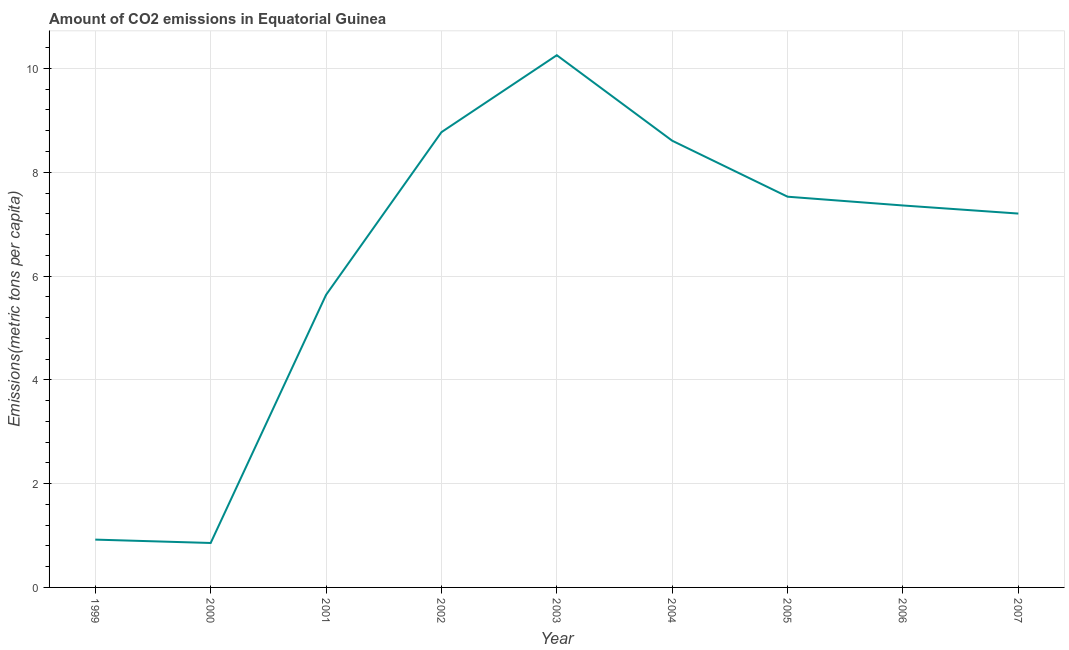What is the amount of co2 emissions in 2002?
Your answer should be compact. 8.77. Across all years, what is the maximum amount of co2 emissions?
Ensure brevity in your answer.  10.26. Across all years, what is the minimum amount of co2 emissions?
Your response must be concise. 0.86. In which year was the amount of co2 emissions minimum?
Make the answer very short. 2000. What is the sum of the amount of co2 emissions?
Your response must be concise. 57.14. What is the difference between the amount of co2 emissions in 2000 and 2006?
Provide a short and direct response. -6.5. What is the average amount of co2 emissions per year?
Your answer should be compact. 6.35. What is the median amount of co2 emissions?
Provide a succinct answer. 7.36. In how many years, is the amount of co2 emissions greater than 0.8 metric tons per capita?
Provide a short and direct response. 9. Do a majority of the years between 2006 and 2007 (inclusive) have amount of co2 emissions greater than 5.2 metric tons per capita?
Keep it short and to the point. Yes. What is the ratio of the amount of co2 emissions in 2004 to that in 2007?
Keep it short and to the point. 1.19. What is the difference between the highest and the second highest amount of co2 emissions?
Provide a short and direct response. 1.48. Is the sum of the amount of co2 emissions in 2001 and 2007 greater than the maximum amount of co2 emissions across all years?
Keep it short and to the point. Yes. What is the difference between the highest and the lowest amount of co2 emissions?
Ensure brevity in your answer.  9.4. Does the amount of co2 emissions monotonically increase over the years?
Offer a very short reply. No. How many lines are there?
Offer a terse response. 1. What is the title of the graph?
Ensure brevity in your answer.  Amount of CO2 emissions in Equatorial Guinea. What is the label or title of the Y-axis?
Your response must be concise. Emissions(metric tons per capita). What is the Emissions(metric tons per capita) of 1999?
Provide a succinct answer. 0.92. What is the Emissions(metric tons per capita) in 2000?
Ensure brevity in your answer.  0.86. What is the Emissions(metric tons per capita) of 2001?
Your answer should be very brief. 5.64. What is the Emissions(metric tons per capita) in 2002?
Make the answer very short. 8.77. What is the Emissions(metric tons per capita) in 2003?
Make the answer very short. 10.26. What is the Emissions(metric tons per capita) in 2004?
Make the answer very short. 8.61. What is the Emissions(metric tons per capita) in 2005?
Ensure brevity in your answer.  7.53. What is the Emissions(metric tons per capita) in 2006?
Your answer should be compact. 7.36. What is the Emissions(metric tons per capita) in 2007?
Ensure brevity in your answer.  7.2. What is the difference between the Emissions(metric tons per capita) in 1999 and 2000?
Your response must be concise. 0.07. What is the difference between the Emissions(metric tons per capita) in 1999 and 2001?
Your answer should be compact. -4.72. What is the difference between the Emissions(metric tons per capita) in 1999 and 2002?
Keep it short and to the point. -7.85. What is the difference between the Emissions(metric tons per capita) in 1999 and 2003?
Ensure brevity in your answer.  -9.33. What is the difference between the Emissions(metric tons per capita) in 1999 and 2004?
Keep it short and to the point. -7.69. What is the difference between the Emissions(metric tons per capita) in 1999 and 2005?
Your response must be concise. -6.61. What is the difference between the Emissions(metric tons per capita) in 1999 and 2006?
Your response must be concise. -6.44. What is the difference between the Emissions(metric tons per capita) in 1999 and 2007?
Your answer should be compact. -6.28. What is the difference between the Emissions(metric tons per capita) in 2000 and 2001?
Give a very brief answer. -4.78. What is the difference between the Emissions(metric tons per capita) in 2000 and 2002?
Make the answer very short. -7.92. What is the difference between the Emissions(metric tons per capita) in 2000 and 2003?
Ensure brevity in your answer.  -9.4. What is the difference between the Emissions(metric tons per capita) in 2000 and 2004?
Give a very brief answer. -7.75. What is the difference between the Emissions(metric tons per capita) in 2000 and 2005?
Offer a very short reply. -6.67. What is the difference between the Emissions(metric tons per capita) in 2000 and 2006?
Give a very brief answer. -6.5. What is the difference between the Emissions(metric tons per capita) in 2000 and 2007?
Make the answer very short. -6.35. What is the difference between the Emissions(metric tons per capita) in 2001 and 2002?
Ensure brevity in your answer.  -3.14. What is the difference between the Emissions(metric tons per capita) in 2001 and 2003?
Offer a terse response. -4.62. What is the difference between the Emissions(metric tons per capita) in 2001 and 2004?
Provide a short and direct response. -2.97. What is the difference between the Emissions(metric tons per capita) in 2001 and 2005?
Your answer should be compact. -1.89. What is the difference between the Emissions(metric tons per capita) in 2001 and 2006?
Offer a terse response. -1.72. What is the difference between the Emissions(metric tons per capita) in 2001 and 2007?
Make the answer very short. -1.57. What is the difference between the Emissions(metric tons per capita) in 2002 and 2003?
Provide a succinct answer. -1.48. What is the difference between the Emissions(metric tons per capita) in 2002 and 2004?
Ensure brevity in your answer.  0.16. What is the difference between the Emissions(metric tons per capita) in 2002 and 2005?
Make the answer very short. 1.24. What is the difference between the Emissions(metric tons per capita) in 2002 and 2006?
Keep it short and to the point. 1.41. What is the difference between the Emissions(metric tons per capita) in 2002 and 2007?
Ensure brevity in your answer.  1.57. What is the difference between the Emissions(metric tons per capita) in 2003 and 2004?
Your response must be concise. 1.65. What is the difference between the Emissions(metric tons per capita) in 2003 and 2005?
Provide a succinct answer. 2.73. What is the difference between the Emissions(metric tons per capita) in 2003 and 2006?
Ensure brevity in your answer.  2.9. What is the difference between the Emissions(metric tons per capita) in 2003 and 2007?
Offer a very short reply. 3.05. What is the difference between the Emissions(metric tons per capita) in 2004 and 2005?
Give a very brief answer. 1.08. What is the difference between the Emissions(metric tons per capita) in 2004 and 2006?
Offer a very short reply. 1.25. What is the difference between the Emissions(metric tons per capita) in 2004 and 2007?
Offer a terse response. 1.4. What is the difference between the Emissions(metric tons per capita) in 2005 and 2006?
Offer a terse response. 0.17. What is the difference between the Emissions(metric tons per capita) in 2005 and 2007?
Keep it short and to the point. 0.32. What is the difference between the Emissions(metric tons per capita) in 2006 and 2007?
Your answer should be compact. 0.16. What is the ratio of the Emissions(metric tons per capita) in 1999 to that in 2000?
Provide a short and direct response. 1.08. What is the ratio of the Emissions(metric tons per capita) in 1999 to that in 2001?
Your response must be concise. 0.16. What is the ratio of the Emissions(metric tons per capita) in 1999 to that in 2002?
Ensure brevity in your answer.  0.1. What is the ratio of the Emissions(metric tons per capita) in 1999 to that in 2003?
Make the answer very short. 0.09. What is the ratio of the Emissions(metric tons per capita) in 1999 to that in 2004?
Offer a terse response. 0.11. What is the ratio of the Emissions(metric tons per capita) in 1999 to that in 2005?
Offer a very short reply. 0.12. What is the ratio of the Emissions(metric tons per capita) in 1999 to that in 2006?
Your answer should be compact. 0.12. What is the ratio of the Emissions(metric tons per capita) in 1999 to that in 2007?
Provide a succinct answer. 0.13. What is the ratio of the Emissions(metric tons per capita) in 2000 to that in 2001?
Your answer should be very brief. 0.15. What is the ratio of the Emissions(metric tons per capita) in 2000 to that in 2002?
Offer a terse response. 0.1. What is the ratio of the Emissions(metric tons per capita) in 2000 to that in 2003?
Make the answer very short. 0.08. What is the ratio of the Emissions(metric tons per capita) in 2000 to that in 2004?
Give a very brief answer. 0.1. What is the ratio of the Emissions(metric tons per capita) in 2000 to that in 2005?
Your answer should be compact. 0.11. What is the ratio of the Emissions(metric tons per capita) in 2000 to that in 2006?
Offer a terse response. 0.12. What is the ratio of the Emissions(metric tons per capita) in 2000 to that in 2007?
Provide a succinct answer. 0.12. What is the ratio of the Emissions(metric tons per capita) in 2001 to that in 2002?
Keep it short and to the point. 0.64. What is the ratio of the Emissions(metric tons per capita) in 2001 to that in 2003?
Give a very brief answer. 0.55. What is the ratio of the Emissions(metric tons per capita) in 2001 to that in 2004?
Offer a very short reply. 0.66. What is the ratio of the Emissions(metric tons per capita) in 2001 to that in 2005?
Give a very brief answer. 0.75. What is the ratio of the Emissions(metric tons per capita) in 2001 to that in 2006?
Keep it short and to the point. 0.77. What is the ratio of the Emissions(metric tons per capita) in 2001 to that in 2007?
Make the answer very short. 0.78. What is the ratio of the Emissions(metric tons per capita) in 2002 to that in 2003?
Provide a short and direct response. 0.85. What is the ratio of the Emissions(metric tons per capita) in 2002 to that in 2005?
Your answer should be very brief. 1.17. What is the ratio of the Emissions(metric tons per capita) in 2002 to that in 2006?
Offer a very short reply. 1.19. What is the ratio of the Emissions(metric tons per capita) in 2002 to that in 2007?
Offer a very short reply. 1.22. What is the ratio of the Emissions(metric tons per capita) in 2003 to that in 2004?
Provide a succinct answer. 1.19. What is the ratio of the Emissions(metric tons per capita) in 2003 to that in 2005?
Your answer should be very brief. 1.36. What is the ratio of the Emissions(metric tons per capita) in 2003 to that in 2006?
Provide a short and direct response. 1.39. What is the ratio of the Emissions(metric tons per capita) in 2003 to that in 2007?
Keep it short and to the point. 1.42. What is the ratio of the Emissions(metric tons per capita) in 2004 to that in 2005?
Your response must be concise. 1.14. What is the ratio of the Emissions(metric tons per capita) in 2004 to that in 2006?
Provide a succinct answer. 1.17. What is the ratio of the Emissions(metric tons per capita) in 2004 to that in 2007?
Your answer should be very brief. 1.2. What is the ratio of the Emissions(metric tons per capita) in 2005 to that in 2006?
Offer a very short reply. 1.02. What is the ratio of the Emissions(metric tons per capita) in 2005 to that in 2007?
Your answer should be very brief. 1.04. 